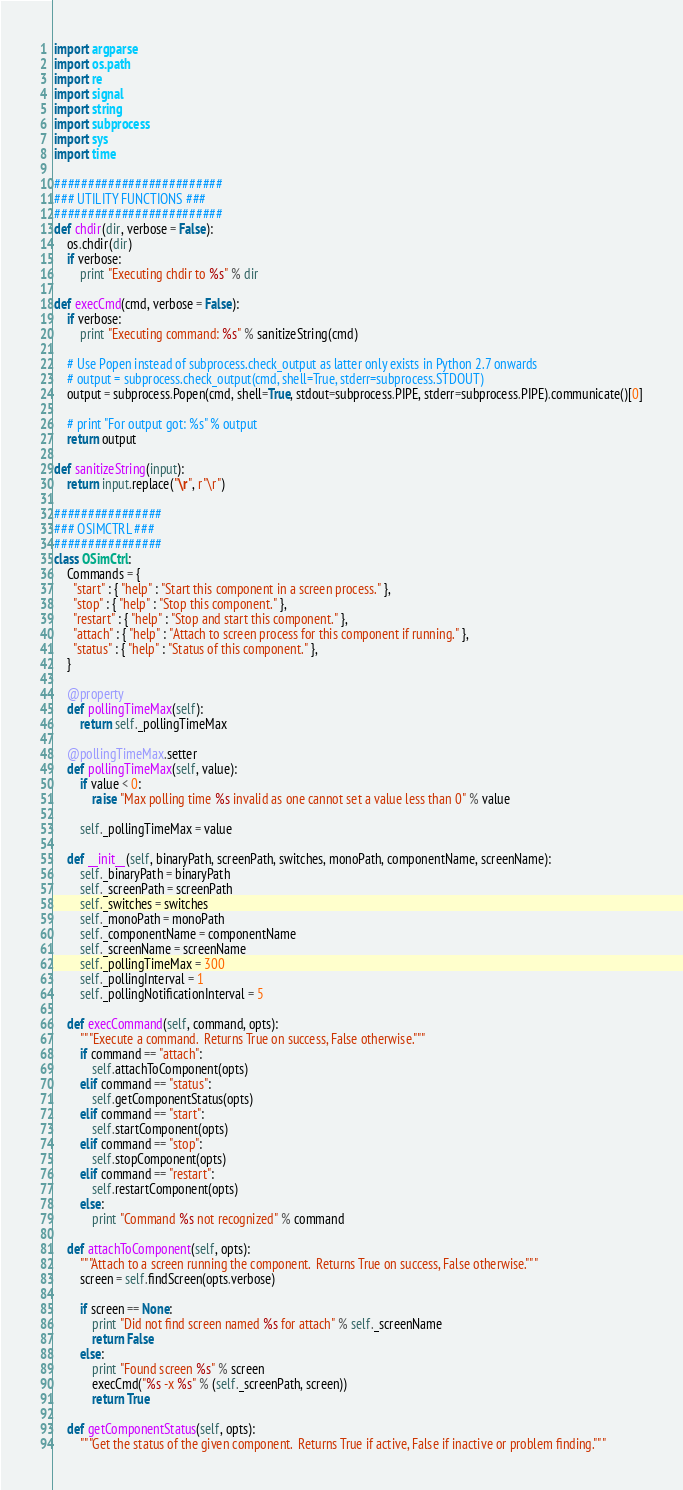Convert code to text. <code><loc_0><loc_0><loc_500><loc_500><_Python_>import argparse
import os.path
import re
import signal
import string
import subprocess
import sys
import time

#########################
### UTILITY FUNCTIONS ###
#########################
def chdir(dir, verbose = False):
    os.chdir(dir)
    if verbose:
    	print "Executing chdir to %s" % dir

def execCmd(cmd, verbose = False):
    if verbose:
    	print "Executing command: %s" % sanitizeString(cmd)

    # Use Popen instead of subprocess.check_output as latter only exists in Python 2.7 onwards
    # output = subprocess.check_output(cmd, shell=True, stderr=subprocess.STDOUT)
    output = subprocess.Popen(cmd, shell=True, stdout=subprocess.PIPE, stderr=subprocess.PIPE).communicate()[0]

    # print "For output got: %s" % output
    return output

def sanitizeString(input):
    return input.replace("\r", r"\r")

################
### OSIMCTRL ###
################
class OSimCtrl:
    Commands = {
      "start" : { "help" : "Start this component in a screen process." },
      "stop" : { "help" : "Stop this component." },
      "restart" : { "help" : "Stop and start this component." },
      "attach" : { "help" : "Attach to screen process for this component if running." },
      "status" : { "help" : "Status of this component." },
    }

    @property
    def pollingTimeMax(self):
        return self._pollingTimeMax

    @pollingTimeMax.setter
    def pollingTimeMax(self, value):
        if value < 0:
            raise "Max polling time %s invalid as one cannot set a value less than 0" % value

        self._pollingTimeMax = value

    def __init__(self, binaryPath, screenPath, switches, monoPath, componentName, screenName):
        self._binaryPath = binaryPath
        self._screenPath = screenPath
        self._switches = switches
        self._monoPath = monoPath
        self._componentName = componentName
        self._screenName = screenName
        self._pollingTimeMax = 300
        self._pollingInterval = 1
        self._pollingNotificationInterval = 5

    def execCommand(self, command, opts):
        """Execute a command.  Returns True on success, False otherwise."""
        if command == "attach":
            self.attachToComponent(opts)
        elif command == "status":
            self.getComponentStatus(opts)
        elif command == "start":
            self.startComponent(opts)
        elif command == "stop":
            self.stopComponent(opts)
        elif command == "restart":
            self.restartComponent(opts)
        else:
            print "Command %s not recognized" % command

    def attachToComponent(self, opts):
        """Attach to a screen running the component.  Returns True on success, False otherwise."""
        screen = self.findScreen(opts.verbose)

        if screen == None:
            print "Did not find screen named %s for attach" % self._screenName
            return False
        else:
            print "Found screen %s" % screen
            execCmd("%s -x %s" % (self._screenPath, screen))
            return True

    def getComponentStatus(self, opts):
        """Get the status of the given component.  Returns True if active, False if inactive or problem finding."""
</code> 